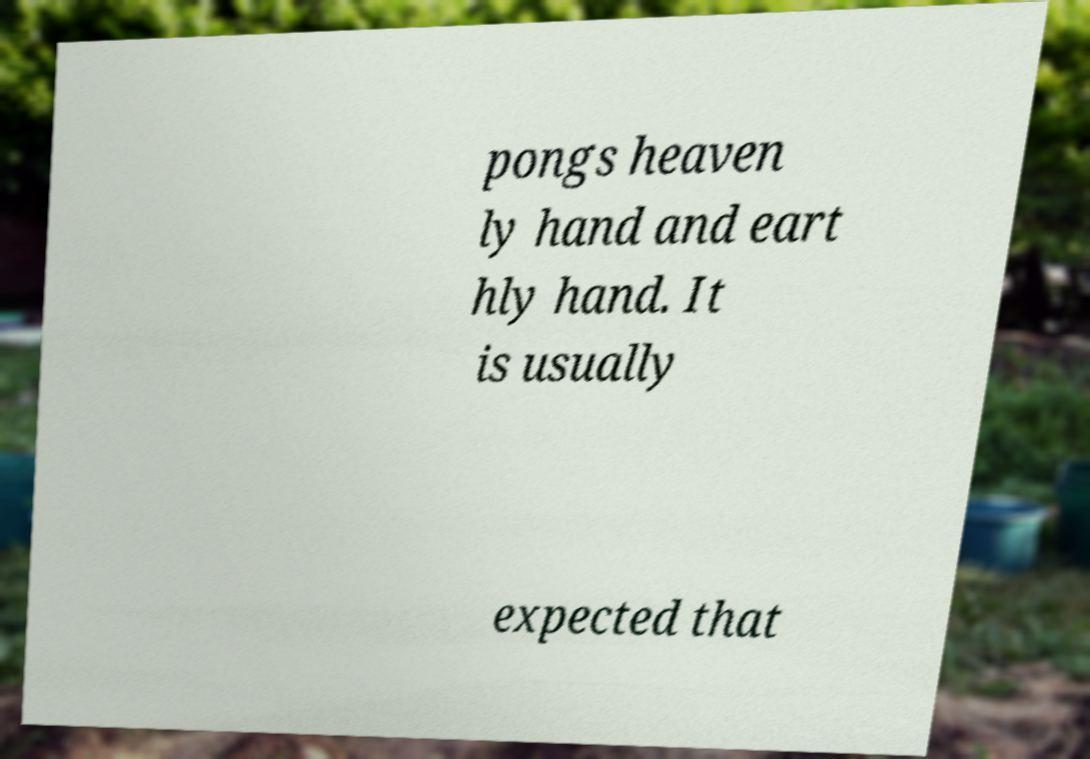Could you extract and type out the text from this image? pongs heaven ly hand and eart hly hand. It is usually expected that 